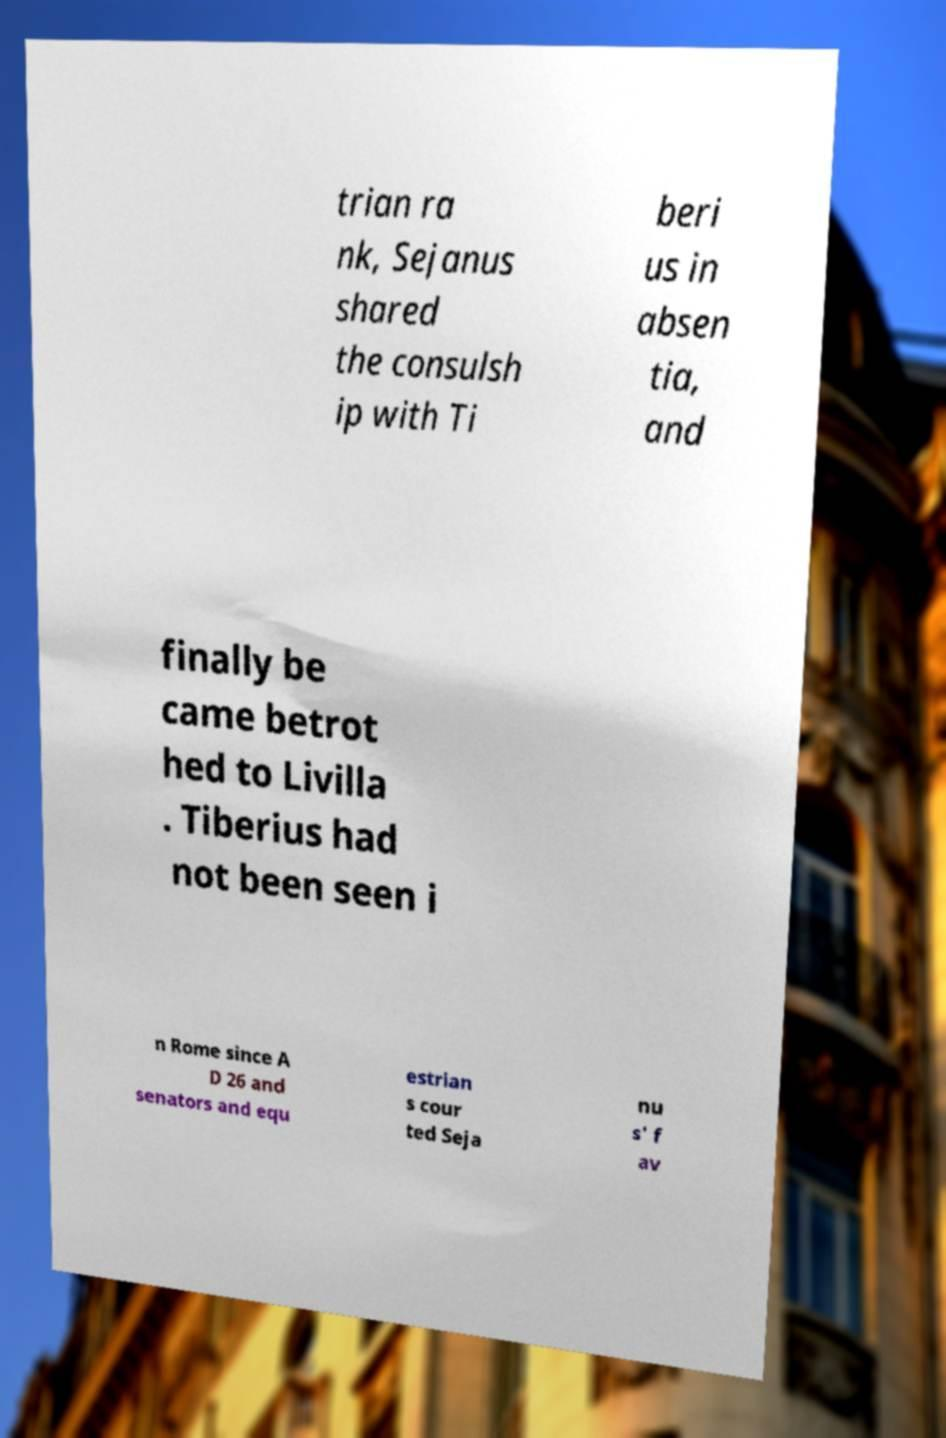Can you read and provide the text displayed in the image?This photo seems to have some interesting text. Can you extract and type it out for me? trian ra nk, Sejanus shared the consulsh ip with Ti beri us in absen tia, and finally be came betrot hed to Livilla . Tiberius had not been seen i n Rome since A D 26 and senators and equ estrian s cour ted Seja nu s' f av 